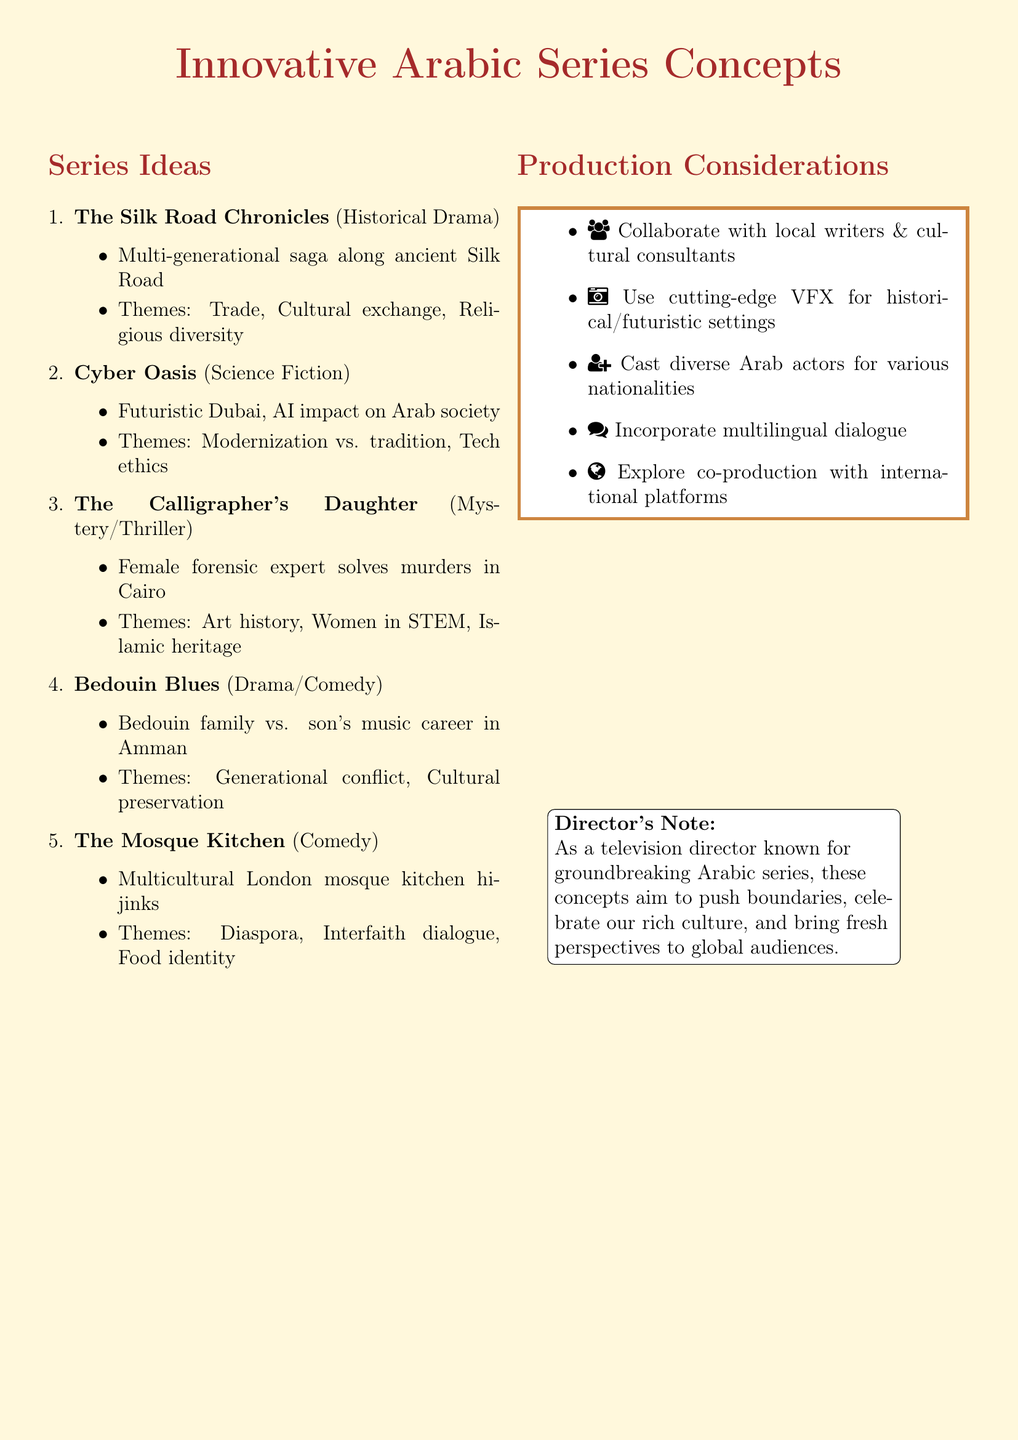What is the title of the historical drama series? The document lists several series concepts, including "The Silk Road Chronicles" as the historical drama title.
Answer: The Silk Road Chronicles How many series ideas are listed in the document? The document enumerates five innovative series concepts, as seen in the list provided.
Answer: Five Which cultural theme is associated with "Cyber Oasis"? The "Cyber Oasis" series discusses themes like modernization vs. tradition among others, specifically addressing modern societal changes.
Answer: Modernization vs. tradition What is the primary setting of "The Mosque Kitchen"? The series "The Mosque Kitchen" is set in a multicultural mosque in London, highlighting community interactions through food.
Answer: Multicultural London What profession is highlighted in "The Calligrapher's Daughter"? In "The Calligrapher's Daughter," the main character is a forensic expert, emphasizing women's roles in STEM fields.
Answer: Forensic expert What genre does "Bedouin Blues" belong to? The genre of the series "Bedouin Blues" is categorized as drama/comedy, combining elements of both genres in its storytelling.
Answer: Drama/Comedy Which concept emphasizes technological ethics? The "Cyber Oasis" series focuses on technological ethics as part of its exploration of advanced AI in society.
Answer: Cyber Oasis How does the document suggest incorporating language? The suggestions include incorporating multilingual dialogue to reflect the historical and cultural diversity of the Arab world, enhancing authenticity.
Answer: Multilingual dialogue 